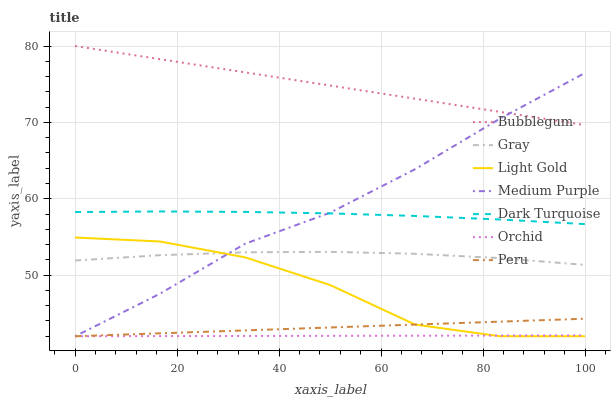Does Orchid have the minimum area under the curve?
Answer yes or no. Yes. Does Bubblegum have the maximum area under the curve?
Answer yes or no. Yes. Does Dark Turquoise have the minimum area under the curve?
Answer yes or no. No. Does Dark Turquoise have the maximum area under the curve?
Answer yes or no. No. Is Bubblegum the smoothest?
Answer yes or no. Yes. Is Light Gold the roughest?
Answer yes or no. Yes. Is Dark Turquoise the smoothest?
Answer yes or no. No. Is Dark Turquoise the roughest?
Answer yes or no. No. Does Medium Purple have the lowest value?
Answer yes or no. Yes. Does Dark Turquoise have the lowest value?
Answer yes or no. No. Does Bubblegum have the highest value?
Answer yes or no. Yes. Does Dark Turquoise have the highest value?
Answer yes or no. No. Is Dark Turquoise less than Bubblegum?
Answer yes or no. Yes. Is Dark Turquoise greater than Light Gold?
Answer yes or no. Yes. Does Orchid intersect Light Gold?
Answer yes or no. Yes. Is Orchid less than Light Gold?
Answer yes or no. No. Is Orchid greater than Light Gold?
Answer yes or no. No. Does Dark Turquoise intersect Bubblegum?
Answer yes or no. No. 